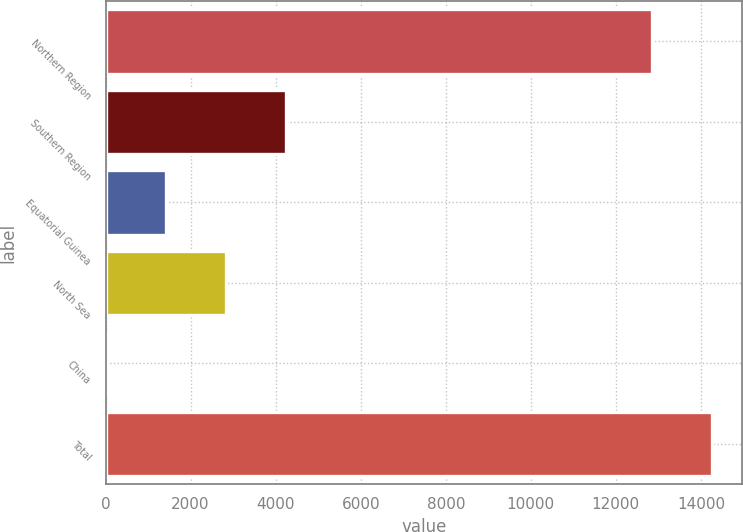<chart> <loc_0><loc_0><loc_500><loc_500><bar_chart><fcel>Northern Region<fcel>Southern Region<fcel>Equatorial Guinea<fcel>North Sea<fcel>China<fcel>Total<nl><fcel>12853<fcel>4247.8<fcel>1426.6<fcel>2837.2<fcel>16<fcel>14263.6<nl></chart> 